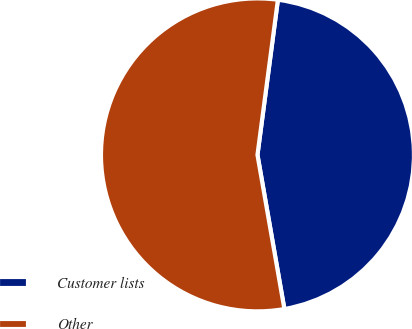<chart> <loc_0><loc_0><loc_500><loc_500><pie_chart><fcel>Customer lists<fcel>Other<nl><fcel>45.16%<fcel>54.84%<nl></chart> 